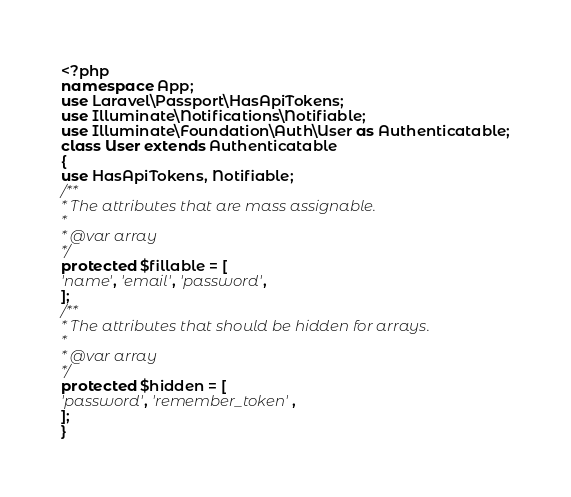<code> <loc_0><loc_0><loc_500><loc_500><_PHP_><?php
namespace App;
use Laravel\Passport\HasApiTokens;
use Illuminate\Notifications\Notifiable;
use Illuminate\Foundation\Auth\User as Authenticatable;
class User extends Authenticatable
{
use HasApiTokens, Notifiable;
/**
* The attributes that are mass assignable.
*
* @var array
*/
protected $fillable = [
'name', 'email', 'password',
];
/**
* The attributes that should be hidden for arrays.
*
* @var array
*/
protected $hidden = [
'password', 'remember_token',
];
}</code> 